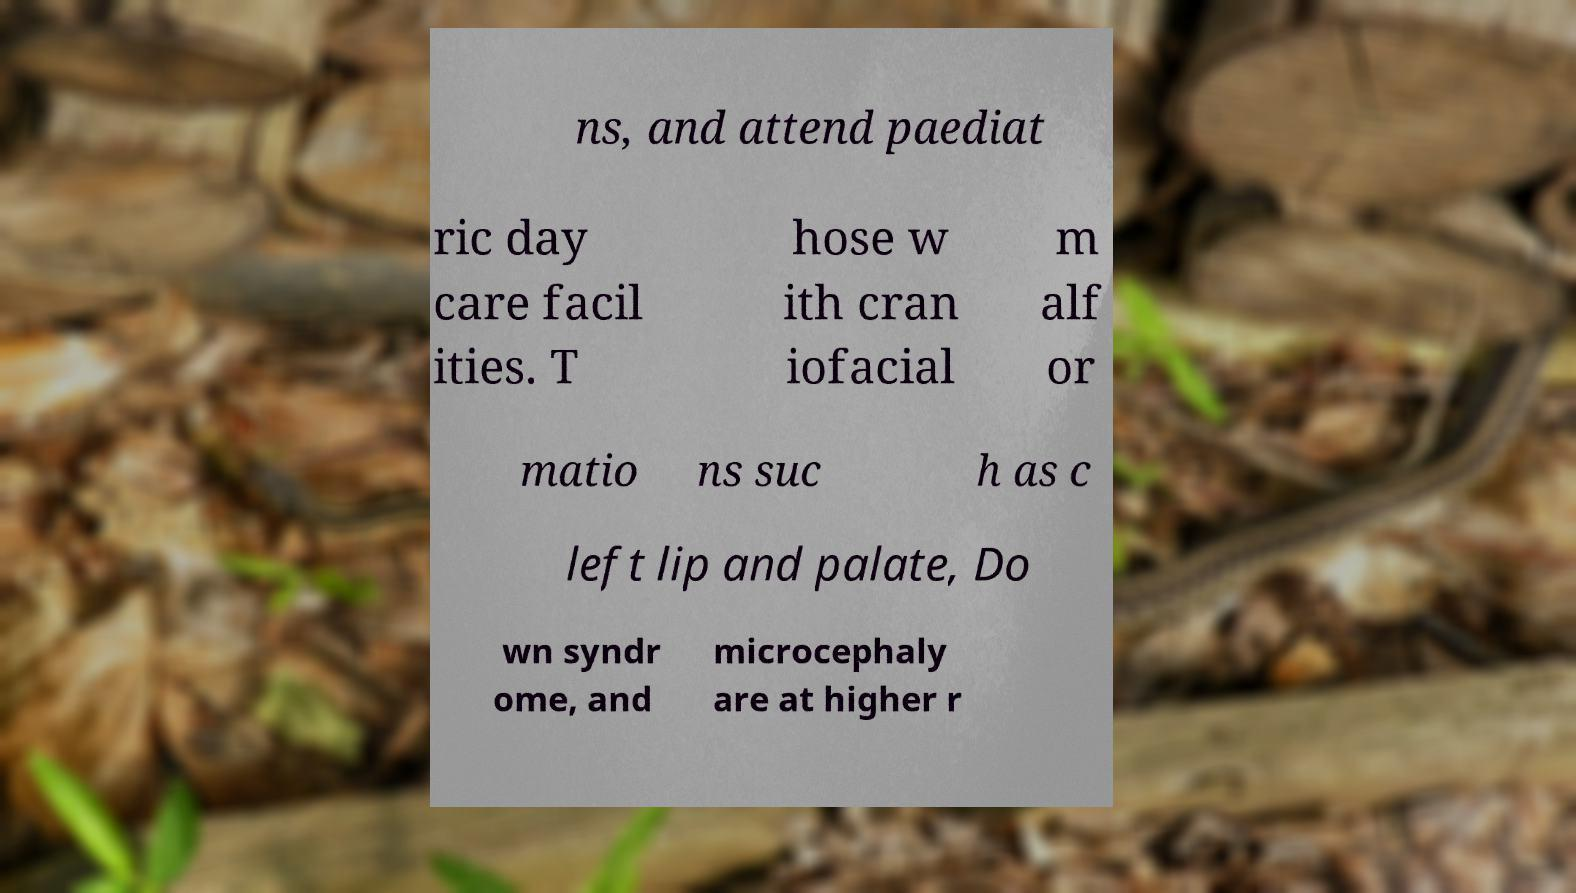What messages or text are displayed in this image? I need them in a readable, typed format. ns, and attend paediat ric day care facil ities. T hose w ith cran iofacial m alf or matio ns suc h as c left lip and palate, Do wn syndr ome, and microcephaly are at higher r 